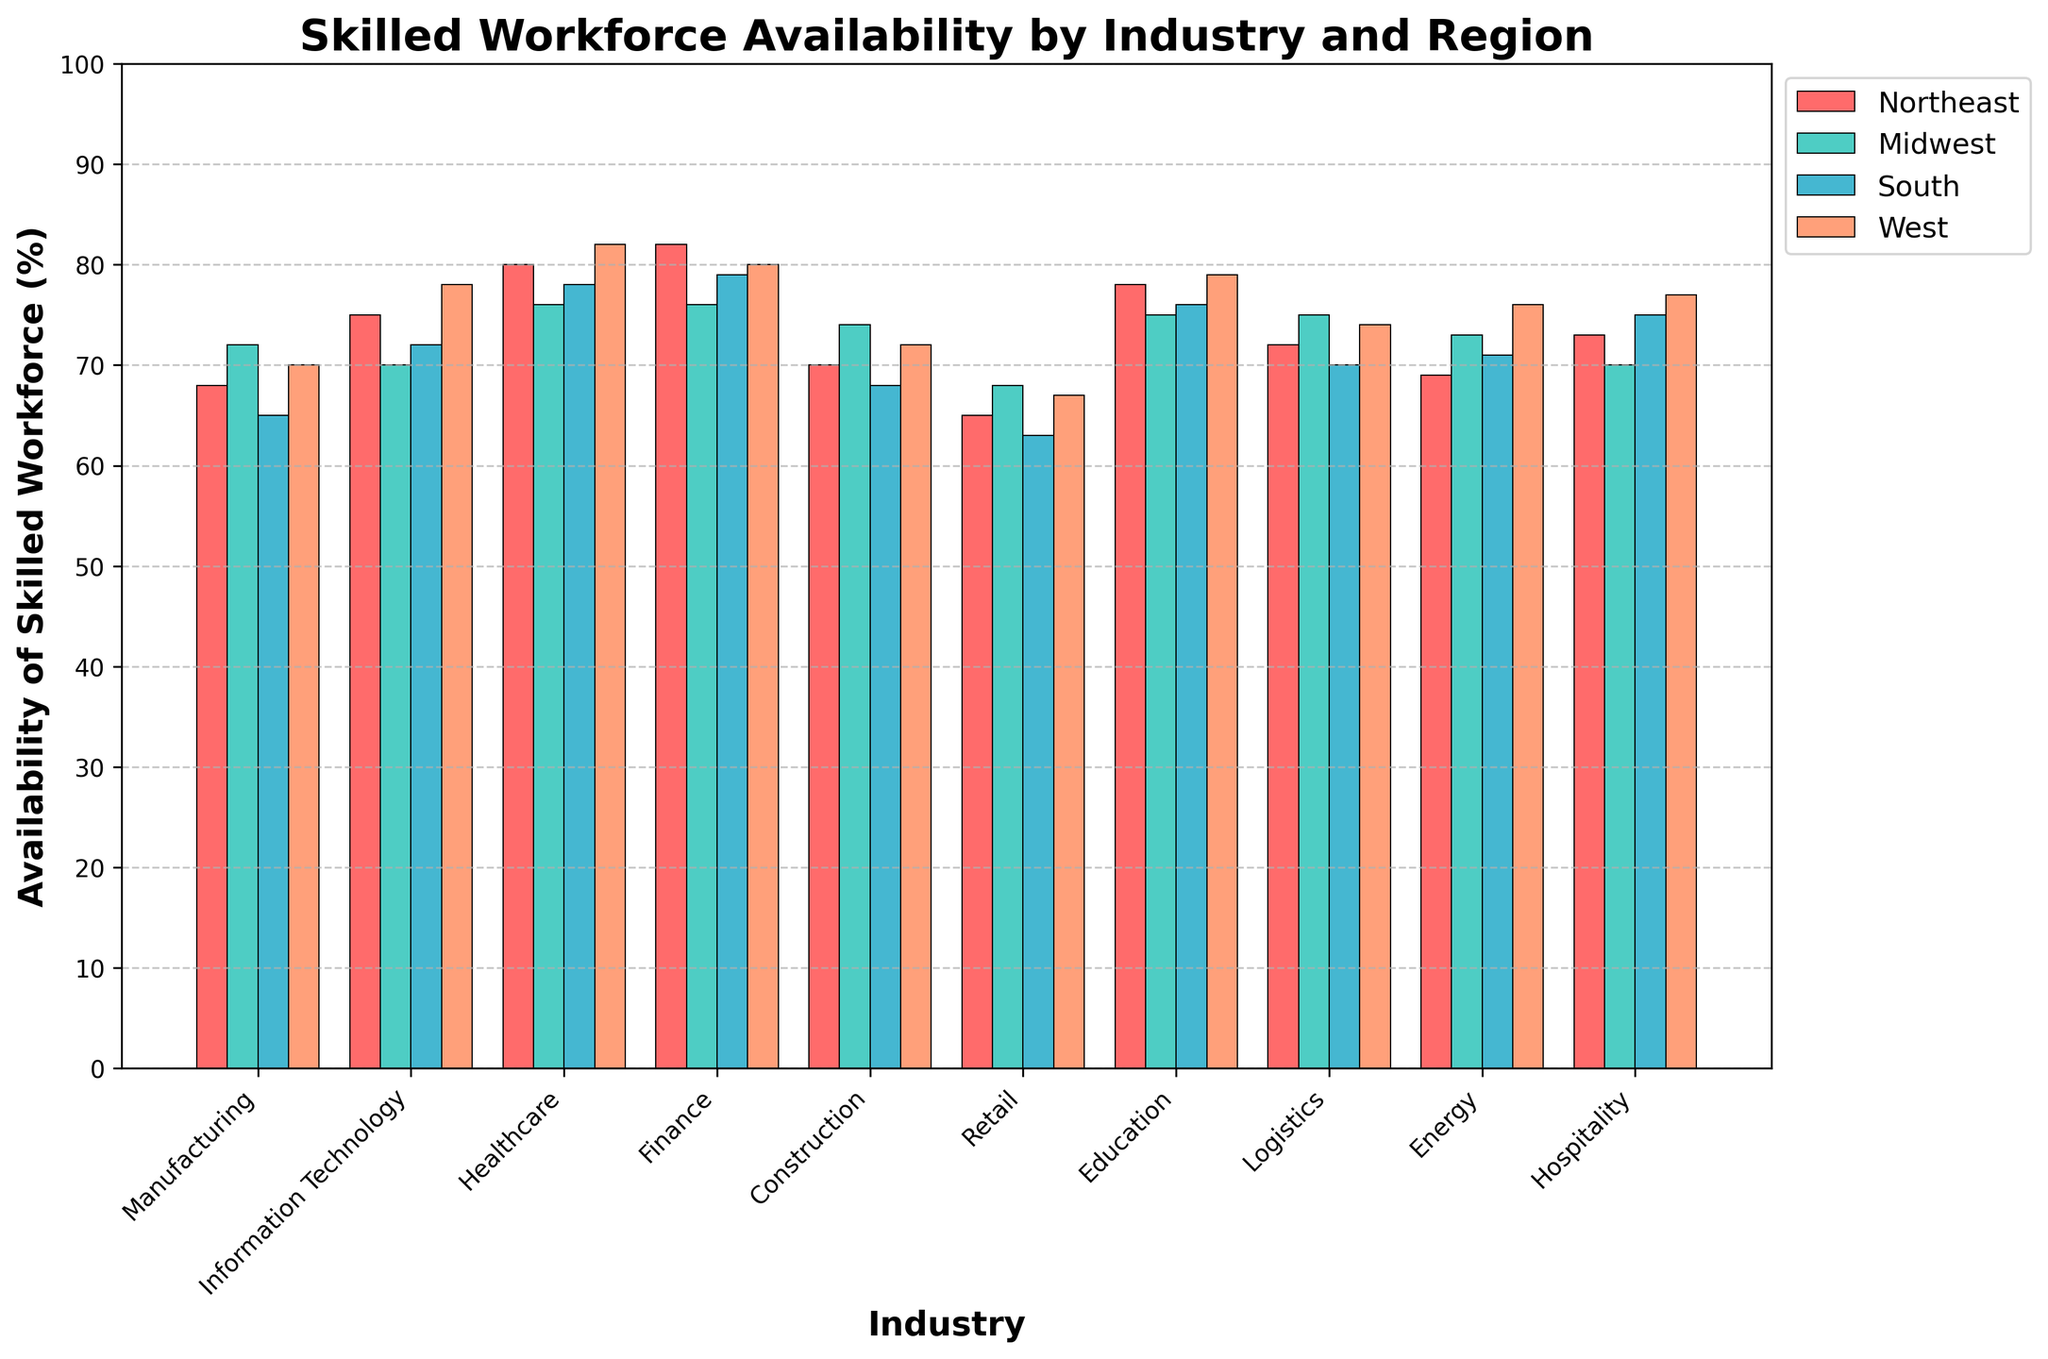Which industry has the highest availability of a skilled workforce in the West? The West region's highest bar represents Healthcare at 82%, which is the highest value among all industries in the West.
Answer: Healthcare Which region has the lowest availability of skilled workforce in the Retail industry? The Retail industry's bars show South with the lowest value at 63%.
Answer: South What is the average availability of a skilled workforce in the Midwest region across all industries? Sum the values for the Midwest (72 + 70 + 76 + 76 + 74 + 68 + 75 + 75 + 73 + 70 = 729) and divide by the number of industries (10). The average is 729 / 10 = 72.9%.
Answer: 72.9% How much higher is the availability of skilled workforce in the Finance sector in the Northeast compared to the South? Northeast has 82% and South has 79% availability in Finance. The difference is 82% - 79% = 3%.
Answer: 3% Which two industries have the same availability of skilled workforce in the West? Bars in the West region indicate that Manufacturing and Construction both have a 72% availability.
Answer: Manufacturing and Construction Across all regions, which industry has the most consistent availability of a skilled workforce? By looking at the heights of the bars, Education has similar values in all regions (78, 75, 76, 79), indicating consistency.
Answer: Education What is the range of workforce availability in the Logistics industry across all regions? The maximum in Logistics is 75% (Midwest), and the minimum is 70% (South). The range is 75% - 70% = 5%.
Answer: 5% How much greater is the average availability of skilled workforce in Healthcare compared to Retail? Average for Healthcare (80+76+78+82)/4 = 79% and for Retail (65+68+63+67)/4 = 65.75%. The difference is 79% - 65.75% = 13.25%.
Answer: 13.25% Which region has equal or greater availability of skilled workforce in more than five industries compared to the Northeast? By comparing values, the West region has higher or equal availability in IT, Healthcare, Education, Logistics, Energy, and Hospitality (6 industries).
Answer: West In which region is the availability of skilled workforce exactly 70% for the Information Technology industry? The Information Technology industry in the Midwest region shows exactly 70%.
Answer: Midwest 